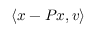Convert formula to latex. <formula><loc_0><loc_0><loc_500><loc_500>\langle x - P x , v \rangle</formula> 